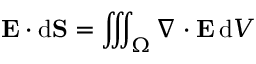Convert formula to latex. <formula><loc_0><loc_0><loc_500><loc_500>E \cdot d S = \iiint _ { \Omega } \nabla \cdot E \, d V</formula> 